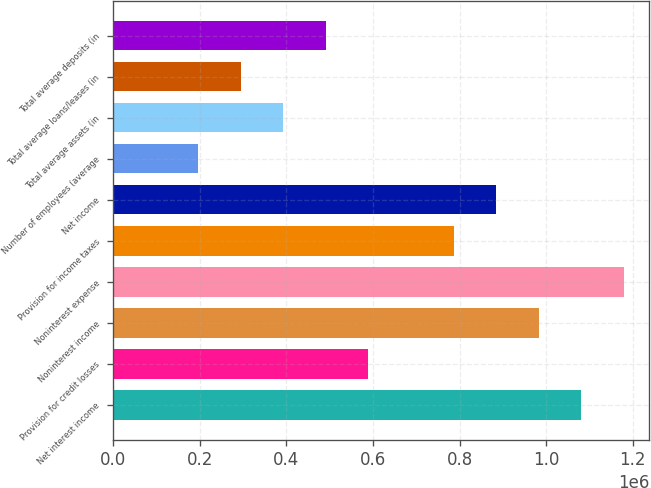Convert chart to OTSL. <chart><loc_0><loc_0><loc_500><loc_500><bar_chart><fcel>Net interest income<fcel>Provision for credit losses<fcel>Noninterest income<fcel>Noninterest expense<fcel>Provision for income taxes<fcel>Net income<fcel>Number of employees (average<fcel>Total average assets (in<fcel>Total average loans/leases (in<fcel>Total average deposits (in<nl><fcel>1.08052e+06<fcel>589373<fcel>982288<fcel>1.17875e+06<fcel>785831<fcel>884059<fcel>196458<fcel>392916<fcel>294687<fcel>491144<nl></chart> 